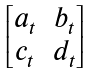Convert formula to latex. <formula><loc_0><loc_0><loc_500><loc_500>\begin{bmatrix} a _ { t } & b _ { t } \\ c _ { t } & d _ { t } \end{bmatrix}</formula> 